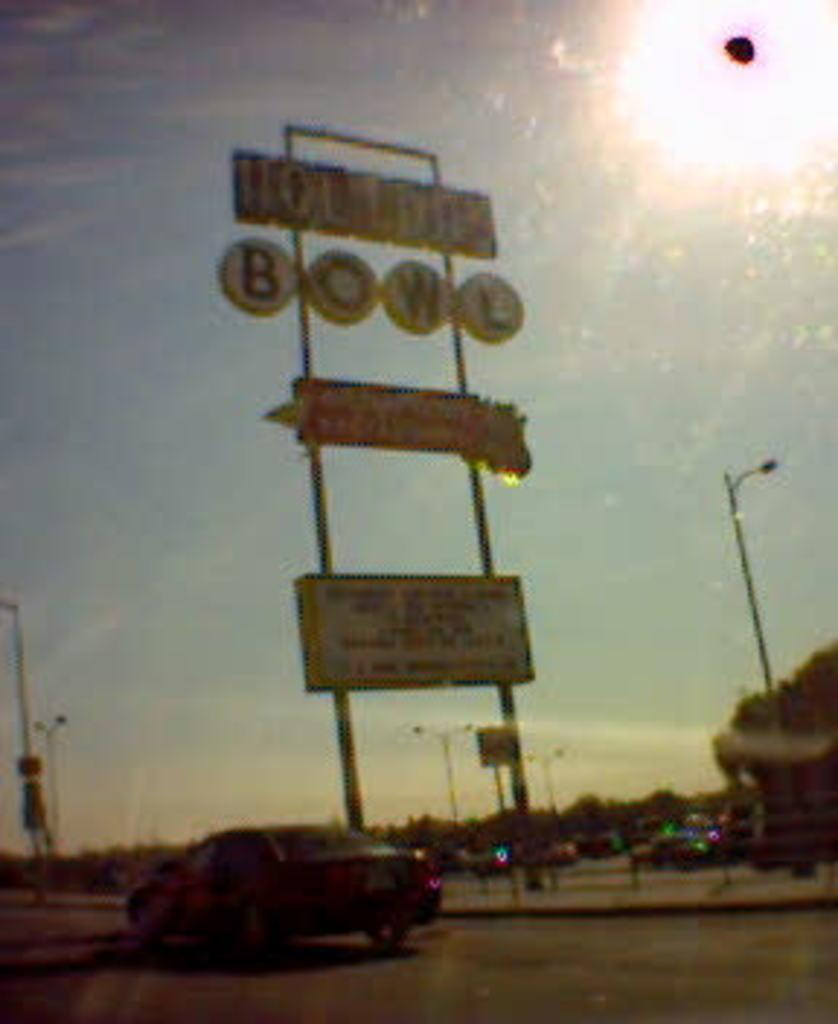What is on the path in the image? There is a vehicle on the path in the image. What can be seen on the poles in the image? Boards are visible on poles in the image. What is in the background of the image? There are trees in the background of the image. How many ducks can be seen swimming in the rainstorm in the image? There are no ducks or rainstorm present in the image. Can you describe the kiss between the two people in the image? There are no people or kisses depicted in the image. 